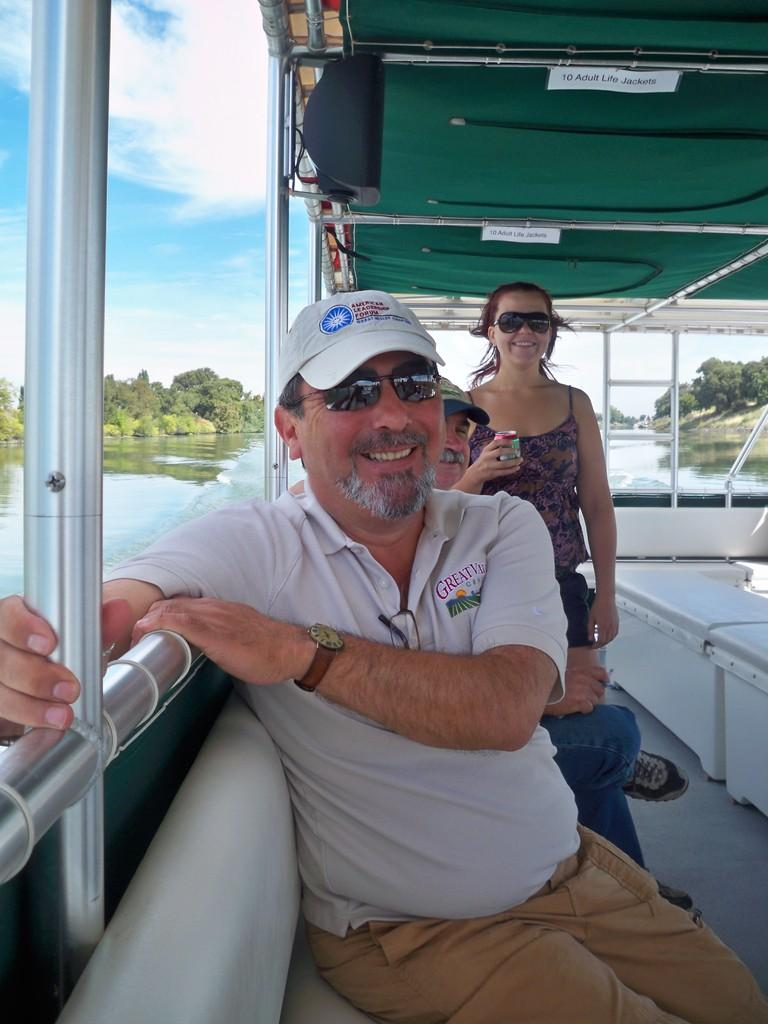Who or what can be seen in the image? There are people in the image. What can be seen in the distance behind the people? There is water, trees, and clouds visible in the background of the image. What type of lace can be seen on the stage in the image? There is no stage or lace present in the image. 